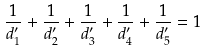Convert formula to latex. <formula><loc_0><loc_0><loc_500><loc_500>\frac { 1 } { d ^ { \prime } _ { 1 } } + \frac { 1 } { d ^ { \prime } _ { 2 } } + \frac { 1 } { d ^ { \prime } _ { 3 } } + \frac { 1 } { d ^ { \prime } _ { 4 } } + \frac { 1 } { d ^ { \prime } _ { 5 } } = 1</formula> 